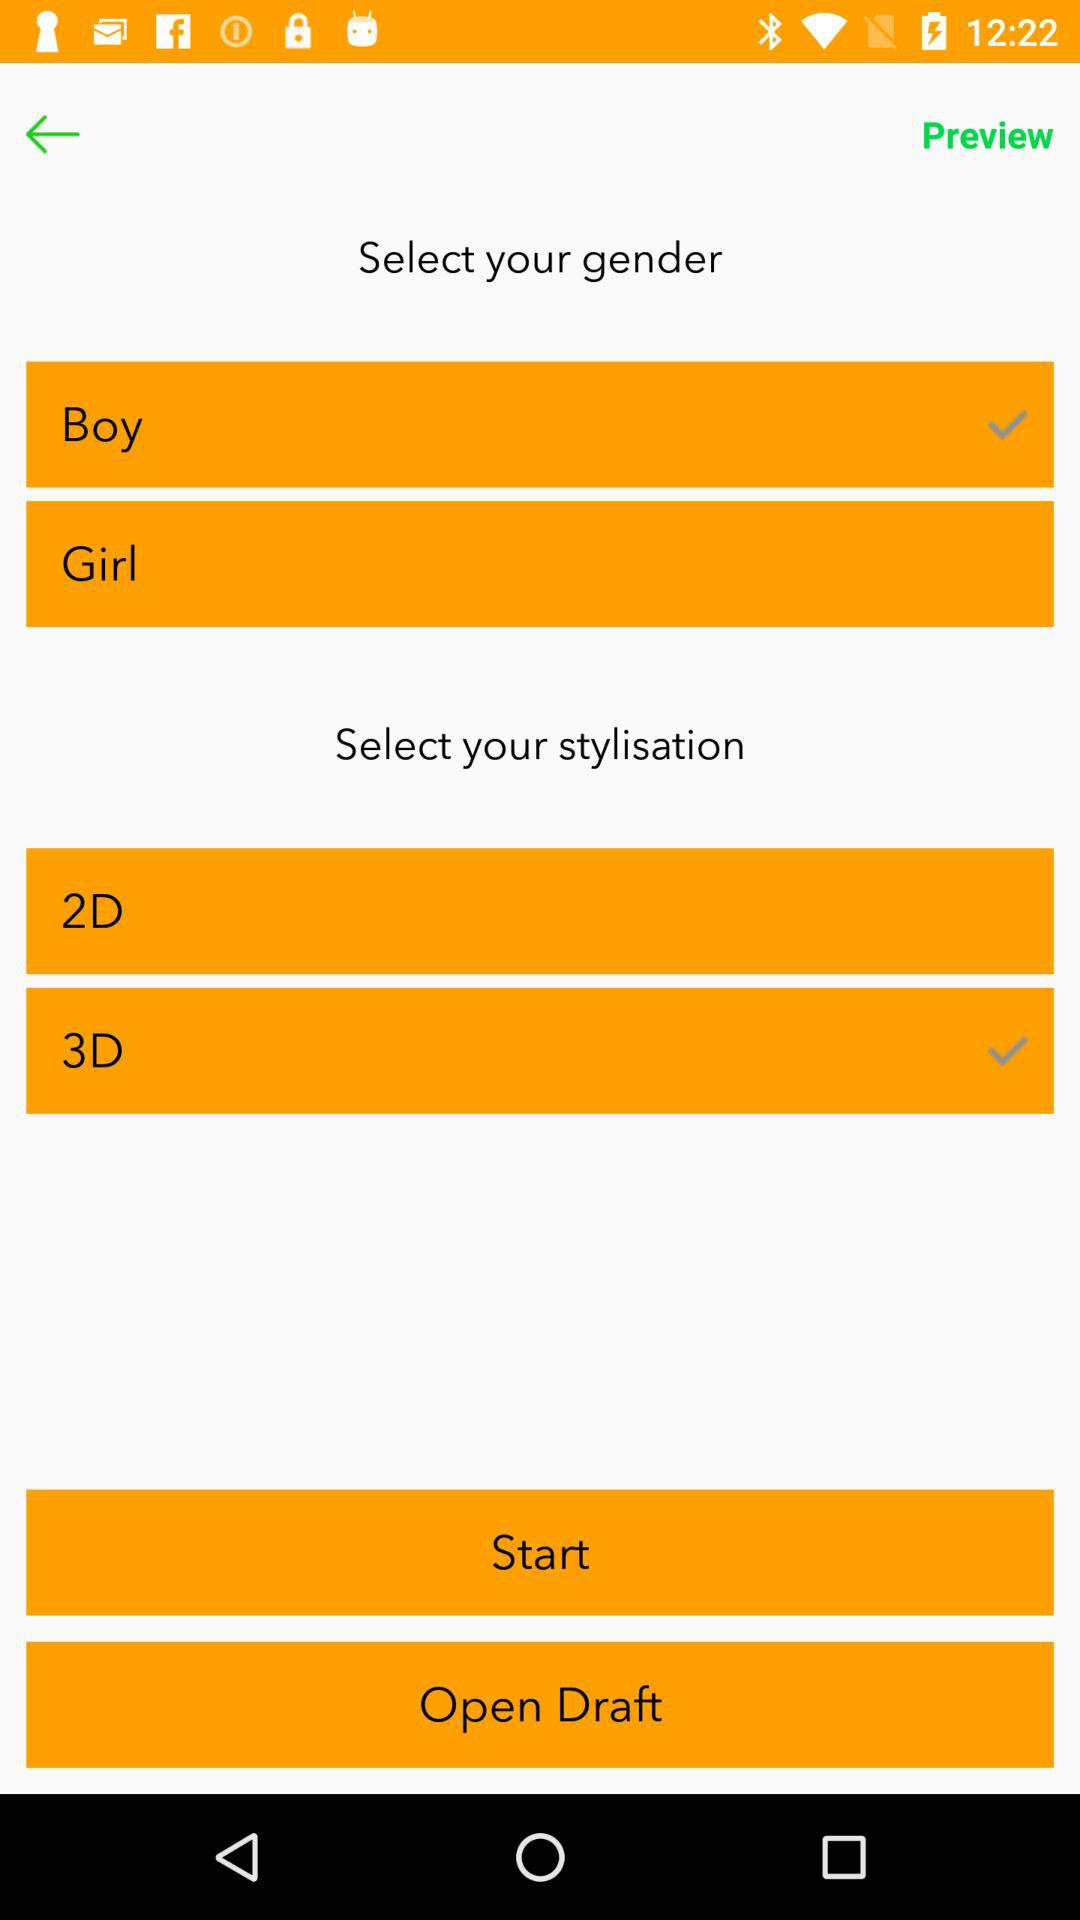How many gender options are there?
Answer the question using a single word or phrase. 2 